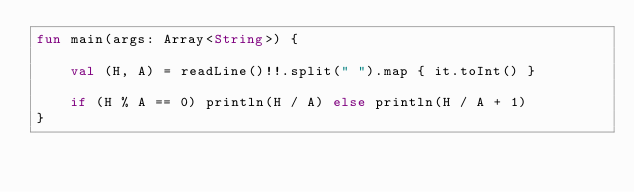Convert code to text. <code><loc_0><loc_0><loc_500><loc_500><_Kotlin_>fun main(args: Array<String>) {

    val (H, A) = readLine()!!.split(" ").map { it.toInt() }

    if (H % A == 0) println(H / A) else println(H / A + 1)
}</code> 